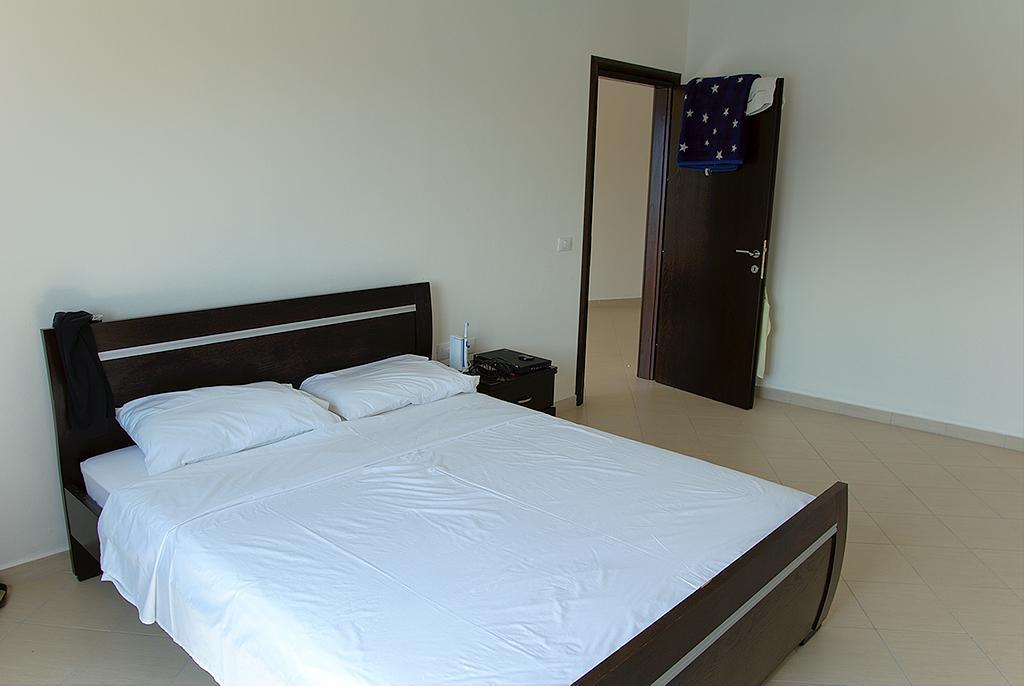Please provide a concise description of this image. It's a bed with white color bed sheets 2 pillows these are the tiles and this is a ball. 